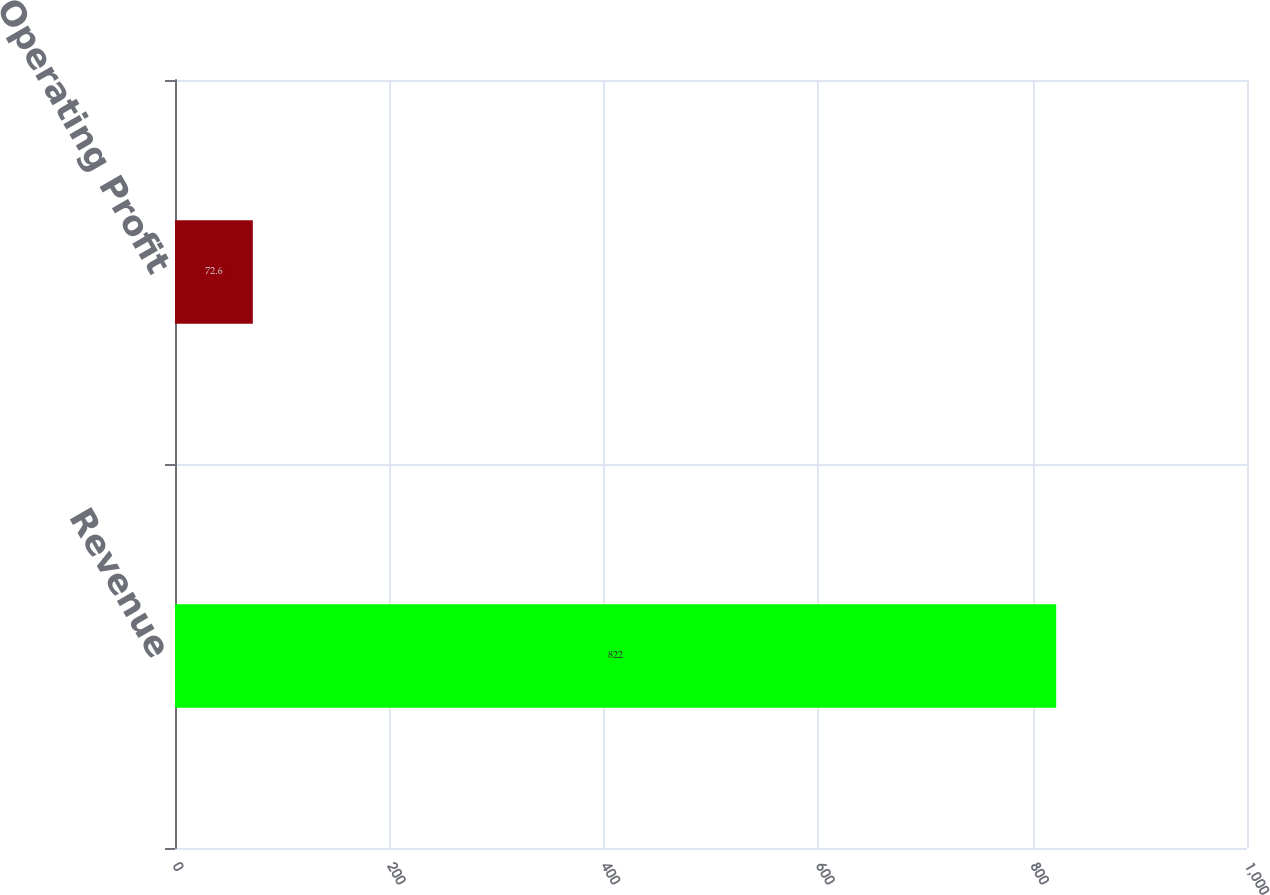Convert chart. <chart><loc_0><loc_0><loc_500><loc_500><bar_chart><fcel>Revenue<fcel>Operating Profit<nl><fcel>822<fcel>72.6<nl></chart> 